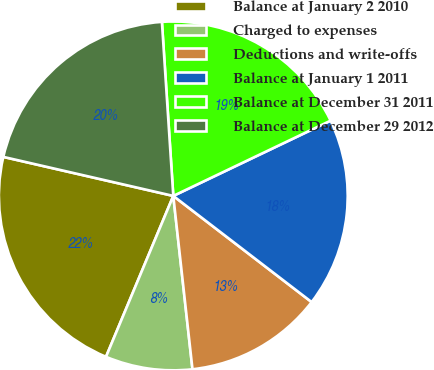<chart> <loc_0><loc_0><loc_500><loc_500><pie_chart><fcel>Balance at January 2 2010<fcel>Charged to expenses<fcel>Deductions and write-offs<fcel>Balance at January 1 2011<fcel>Balance at December 31 2011<fcel>Balance at December 29 2012<nl><fcel>22.29%<fcel>8.06%<fcel>12.83%<fcel>17.52%<fcel>18.94%<fcel>20.37%<nl></chart> 